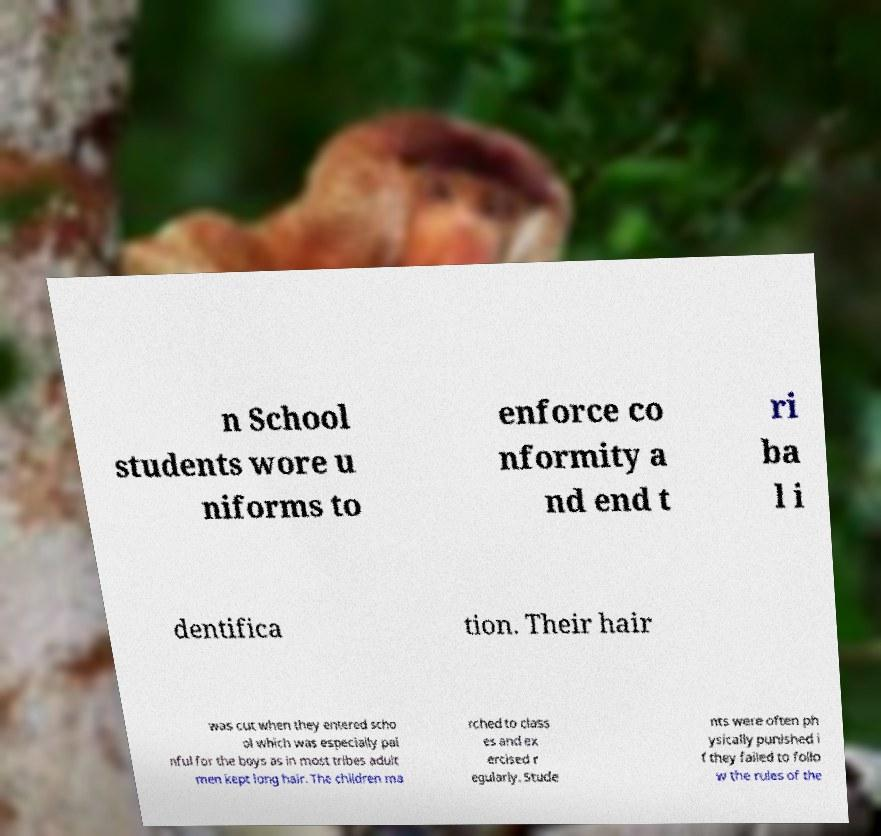Can you accurately transcribe the text from the provided image for me? n School students wore u niforms to enforce co nformity a nd end t ri ba l i dentifica tion. Their hair was cut when they entered scho ol which was especially pai nful for the boys as in most tribes adult men kept long hair. The children ma rched to class es and ex ercised r egularly. Stude nts were often ph ysically punished i f they failed to follo w the rules of the 